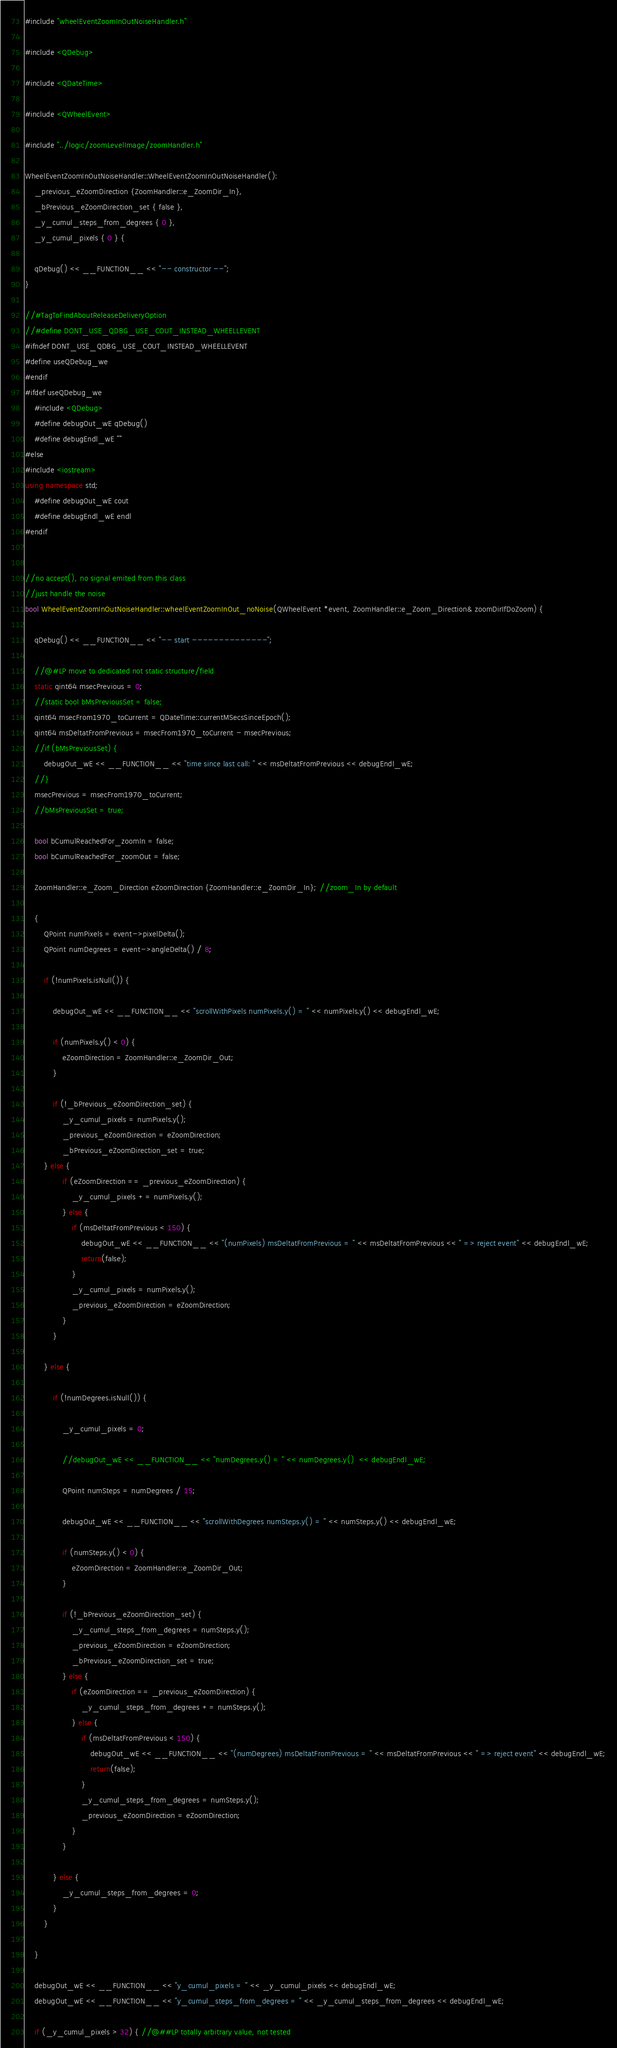<code> <loc_0><loc_0><loc_500><loc_500><_C++_>#include "wheelEventZoomInOutNoiseHandler.h"

#include <QDebug>

#include <QDateTime>

#include <QWheelEvent>

#include "../logic/zoomLevelImage/zoomHandler.h"

WheelEventZoomInOutNoiseHandler::WheelEventZoomInOutNoiseHandler():
    _previous_eZoomDirection {ZoomHandler::e_ZoomDir_In},
    _bPrevious_eZoomDirection_set { false },
    _y_cumul_steps_from_degrees { 0 },
    _y_cumul_pixels { 0 } {

    qDebug() << __FUNCTION__ << "-- constructor --";
}

//#TagToFindAboutReleaseDeliveryOption
//#define DONT_USE_QDBG_USE_COUT_INSTEAD_WHEELLEVENT
#ifndef DONT_USE_QDBG_USE_COUT_INSTEAD_WHEELLEVENT
#define useQDebug_we
#endif
#ifdef useQDebug_we
    #include <QDebug>
    #define debugOut_wE qDebug()
    #define debugEndl_wE ""
#else
#include <iostream>
using namespace std;
    #define debugOut_wE cout
    #define debugEndl_wE endl
#endif


//no accept(), no signal emited from this class
//just handle the noise
bool WheelEventZoomInOutNoiseHandler::wheelEventZoomInOut_noNoise(QWheelEvent *event, ZoomHandler::e_Zoom_Direction& zoomDirIfDoZoom) {
  
    qDebug() << __FUNCTION__ << "-- start --------------";

    //@#LP move to dedicated not static structure/field
    static qint64 msecPrevious = 0;
    //static bool bMsPreviousSet = false;
    qint64 msecFrom1970_toCurrent = QDateTime::currentMSecsSinceEpoch();
    qint64 msDeltatFromPrevious = msecFrom1970_toCurrent - msecPrevious;
    //if (bMsPreviousSet) {
        debugOut_wE << __FUNCTION__ << "time since last call: " << msDeltatFromPrevious << debugEndl_wE;
    //}
    msecPrevious = msecFrom1970_toCurrent;
    //bMsPreviousSet = true;

    bool bCumulReachedFor_zoomIn = false;
    bool bCumulReachedFor_zoomOut = false;

    ZoomHandler::e_Zoom_Direction eZoomDirection {ZoomHandler::e_ZoomDir_In}; //zoom_In by default

    {
        QPoint numPixels = event->pixelDelta();
        QPoint numDegrees = event->angleDelta() / 8;

        if (!numPixels.isNull()) {

            debugOut_wE << __FUNCTION__ << "scrollWithPixels numPixels.y() = " << numPixels.y() << debugEndl_wE;

            if (numPixels.y() < 0) {
                eZoomDirection = ZoomHandler::e_ZoomDir_Out;
            }

            if (!_bPrevious_eZoomDirection_set) {
                _y_cumul_pixels = numPixels.y();
                _previous_eZoomDirection = eZoomDirection;
                _bPrevious_eZoomDirection_set = true;
        } else {
                if (eZoomDirection == _previous_eZoomDirection) {
                    _y_cumul_pixels += numPixels.y();
                } else {
                    if (msDeltatFromPrevious < 150) {
                        debugOut_wE << __FUNCTION__ << "(numPixels) msDeltatFromPrevious = " << msDeltatFromPrevious << " => reject event" << debugEndl_wE;
                        return(false);
                    }
                    _y_cumul_pixels = numPixels.y();
                    _previous_eZoomDirection = eZoomDirection;
                }
            }

        } else {

            if (!numDegrees.isNull()) {

                _y_cumul_pixels = 0;

                //debugOut_wE << __FUNCTION__ << "numDegrees.y() = " << numDegrees.y()  << debugEndl_wE;

                QPoint numSteps = numDegrees / 15;

                debugOut_wE << __FUNCTION__ << "scrollWithDegrees numSteps.y() = " << numSteps.y() << debugEndl_wE;

                if (numSteps.y() < 0) {
                    eZoomDirection = ZoomHandler::e_ZoomDir_Out;
                }

                if (!_bPrevious_eZoomDirection_set) {
                    _y_cumul_steps_from_degrees = numSteps.y();
                    _previous_eZoomDirection = eZoomDirection;
                    _bPrevious_eZoomDirection_set = true;
                } else {
                    if (eZoomDirection == _previous_eZoomDirection) {
                        _y_cumul_steps_from_degrees += numSteps.y();
                    } else {
                        if (msDeltatFromPrevious < 150) {
                            debugOut_wE << __FUNCTION__ << "(numDegrees) msDeltatFromPrevious = " << msDeltatFromPrevious << " => reject event" << debugEndl_wE;
                            return(false);
                        }
                        _y_cumul_steps_from_degrees = numSteps.y();
                        _previous_eZoomDirection = eZoomDirection;
                    }
                }

            } else {
                _y_cumul_steps_from_degrees = 0;
            }
        }

    }

    debugOut_wE << __FUNCTION__ << "y_cumul_pixels = " << _y_cumul_pixels << debugEndl_wE;
    debugOut_wE << __FUNCTION__ << "y_cumul_steps_from_degrees = " << _y_cumul_steps_from_degrees << debugEndl_wE;

    if (_y_cumul_pixels > 32) { //@##LP totally arbitrary value, not tested</code> 